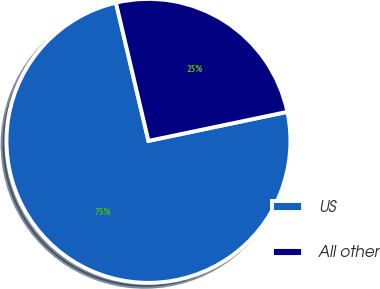<chart> <loc_0><loc_0><loc_500><loc_500><pie_chart><fcel>US<fcel>All other<nl><fcel>74.6%<fcel>25.4%<nl></chart> 